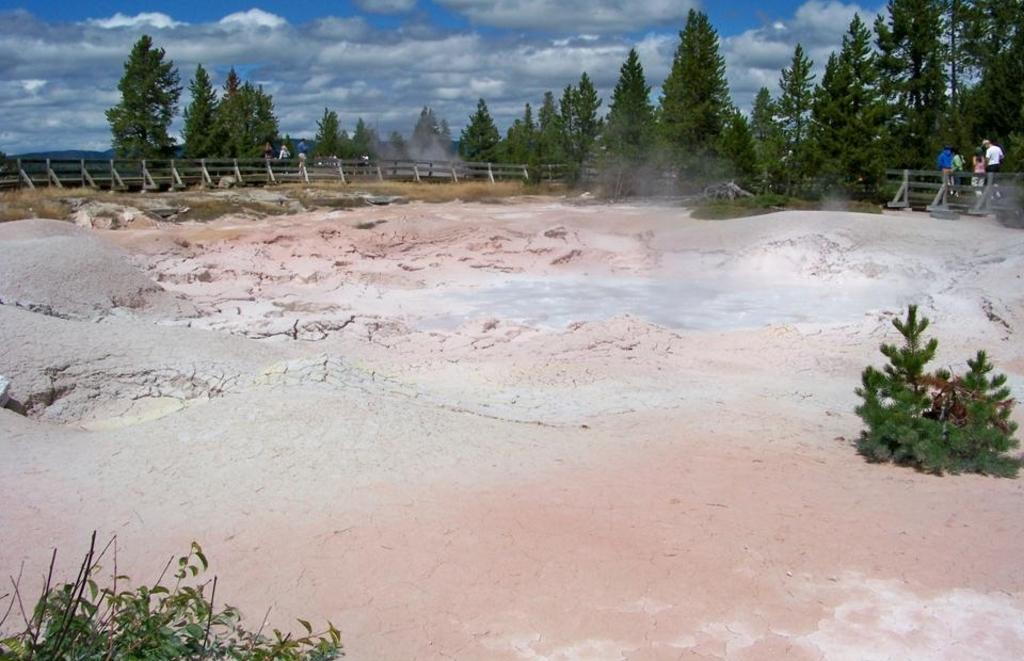What type of vegetation can be seen in the image? There are trees and small plants in the image. What is the condition of the sky in the image? The sky is cloudy in the image. What is the purpose of the fencing in the image? The purpose of the fencing in the image is not specified, but it could be for enclosing an area or providing a boundary. Can you describe the group of people in the image? There is a group of people standing on the ground in the image. What type of zinc is visible on the trees in the image? There is no zinc present on the trees in the image. Can you describe the root system of the plants in the image? The image does not show the root system of the plants; it only shows the visible parts of the trees and small plants. 